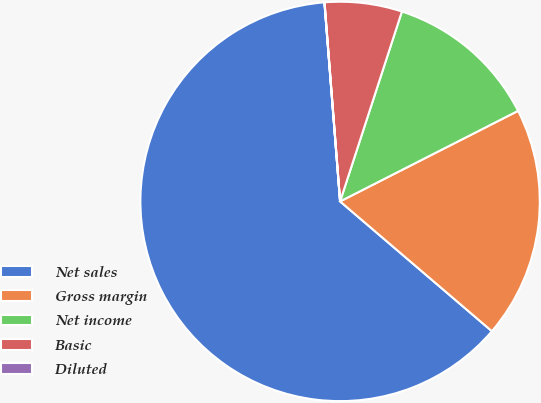Convert chart to OTSL. <chart><loc_0><loc_0><loc_500><loc_500><pie_chart><fcel>Net sales<fcel>Gross margin<fcel>Net income<fcel>Basic<fcel>Diluted<nl><fcel>62.49%<fcel>18.75%<fcel>12.5%<fcel>6.25%<fcel>0.01%<nl></chart> 